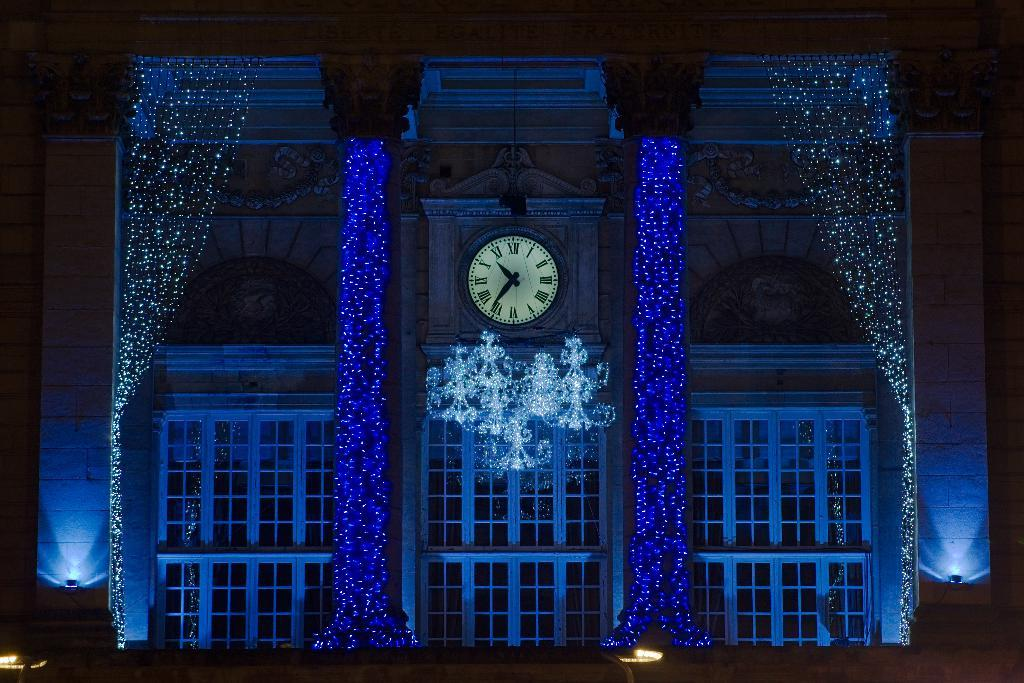What type of structure is visible in the image? There is a building in the image. What feature of the building is mentioned in the facts? The building has lights and windows, and there is a clock on the wall of the building. What type of grain is being cooked on the stove in the image? There is no stove or grain present in the image; it features a building with lights, windows, and a clock on the wall. 